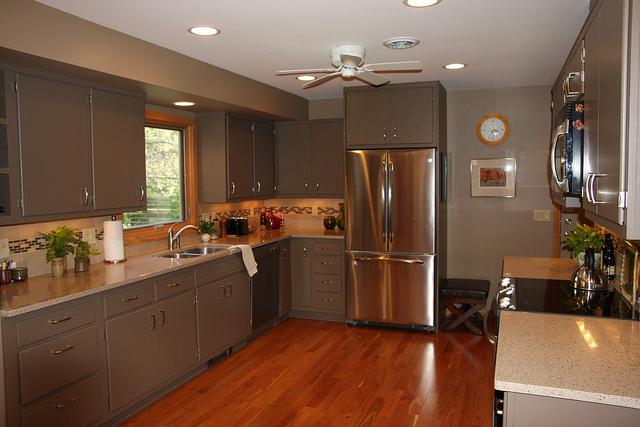How many plants are there?
Write a very short answer. 4. What color is the countertop?
Keep it brief. White. Where is the dish rag?
Keep it brief. Sink. 